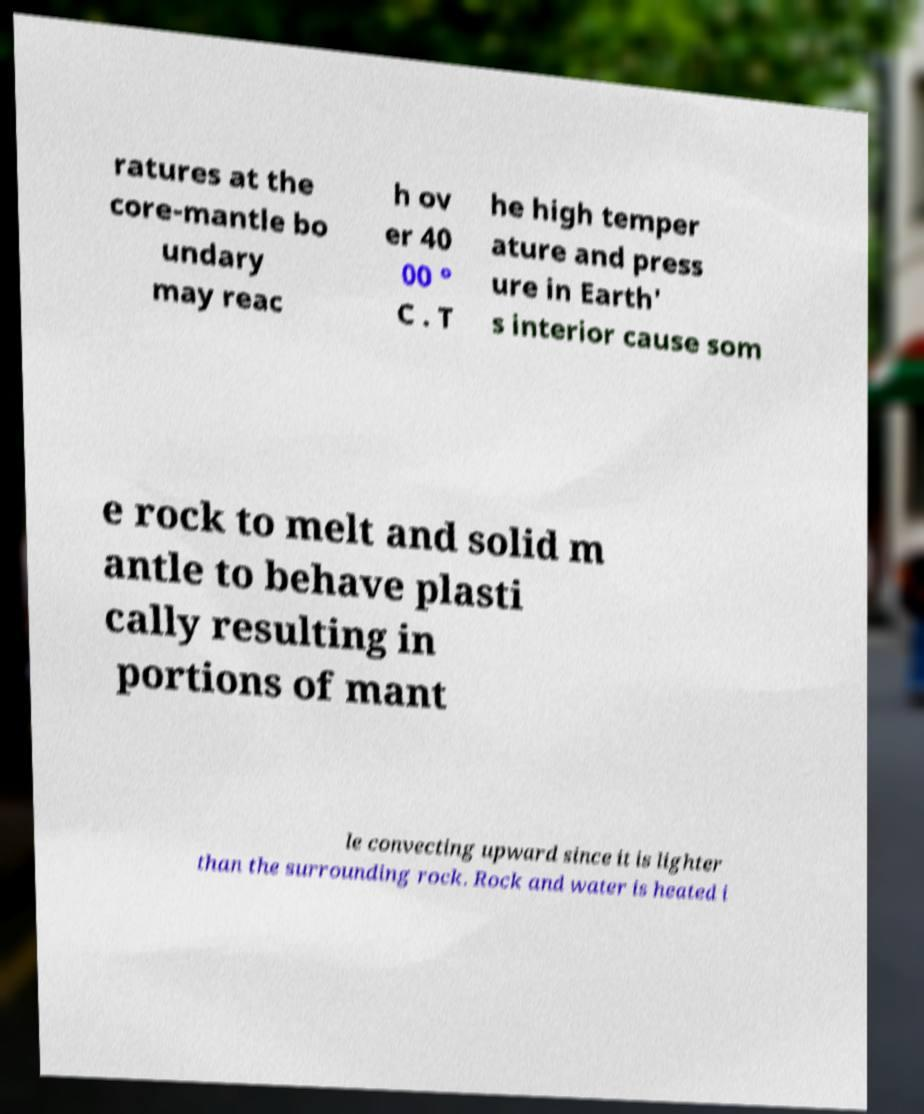Could you extract and type out the text from this image? ratures at the core-mantle bo undary may reac h ov er 40 00 ° C . T he high temper ature and press ure in Earth' s interior cause som e rock to melt and solid m antle to behave plasti cally resulting in portions of mant le convecting upward since it is lighter than the surrounding rock. Rock and water is heated i 